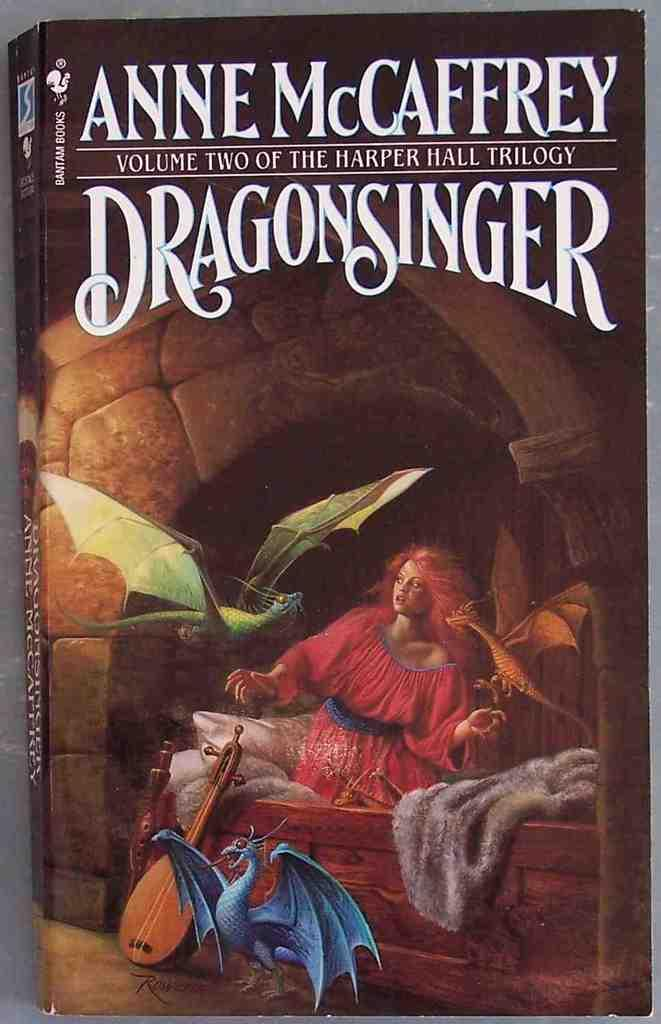<image>
Share a concise interpretation of the image provided. The cover page for Anne McCaffrey's Dragonsinger, features a girl in a red dress surrounded by a blue and green dragon 